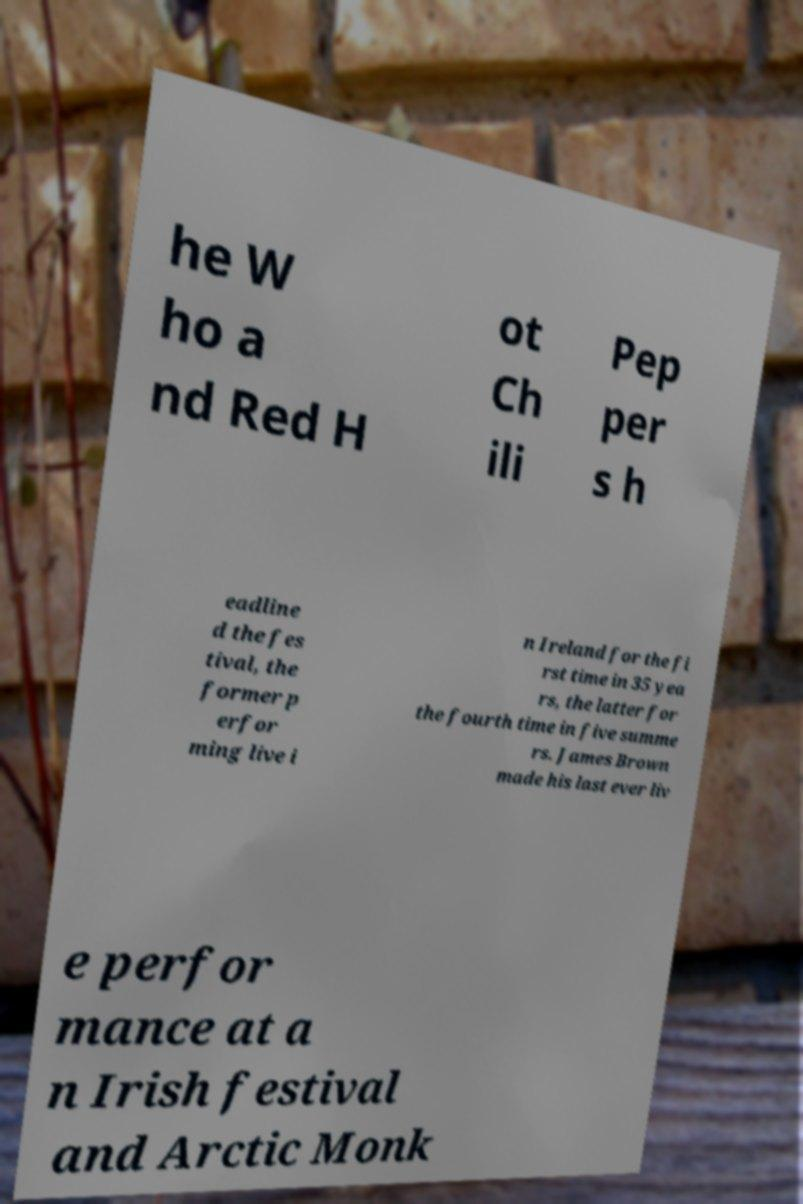Please read and relay the text visible in this image. What does it say? he W ho a nd Red H ot Ch ili Pep per s h eadline d the fes tival, the former p erfor ming live i n Ireland for the fi rst time in 35 yea rs, the latter for the fourth time in five summe rs. James Brown made his last ever liv e perfor mance at a n Irish festival and Arctic Monk 